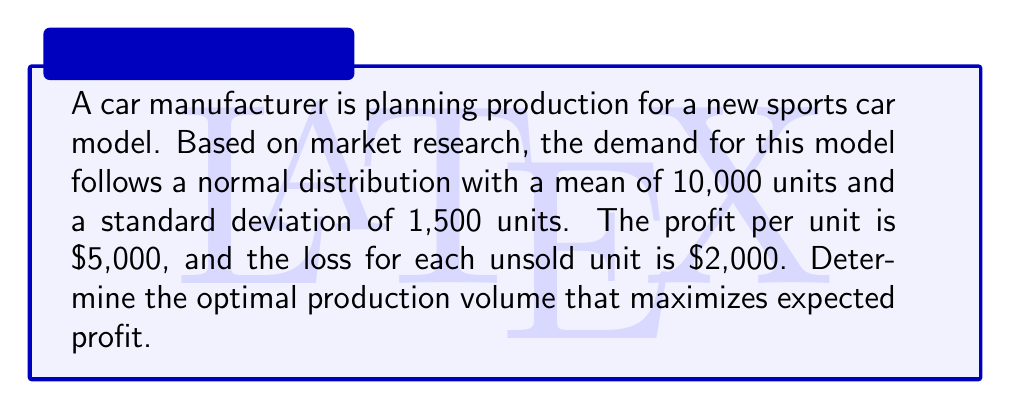Give your solution to this math problem. To solve this problem, we'll use the concept of the critical fractile from the newsvendor model. The steps are as follows:

1) First, calculate the critical fractile (CF):
   $$ CF = \frac{p}{p+h} $$
   where $p$ is the profit per unit and $h$ is the loss per unsold unit.

   $$ CF = \frac{5000}{5000+2000} = \frac{5000}{7000} \approx 0.7143 $$

2) The optimal production quantity is the inverse of the standard normal cumulative distribution function (z-score) at the critical fractile, multiplied by the standard deviation and added to the mean.

3) Find the z-score for 0.7143 using a standard normal table or calculator. This gives approximately 0.5657.

4) Calculate the optimal quantity:
   $$ Q^* = \mu + z \sigma $$
   $$ Q^* = 10000 + (0.5657 \times 1500) = 10848.55 $$

5) Since we can't produce fractional cars, we round to the nearest whole number: 10,849 units.

This quantity balances the risk of overproduction with the risk of lost sales, maximizing expected profit given the demand uncertainty.
Answer: 10,849 units 